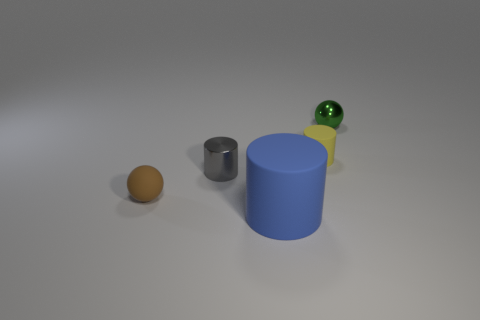Add 5 yellow matte cylinders. How many objects exist? 10 Subtract all spheres. How many objects are left? 3 Subtract 0 cyan balls. How many objects are left? 5 Subtract all big objects. Subtract all yellow things. How many objects are left? 3 Add 4 small balls. How many small balls are left? 6 Add 1 red objects. How many red objects exist? 1 